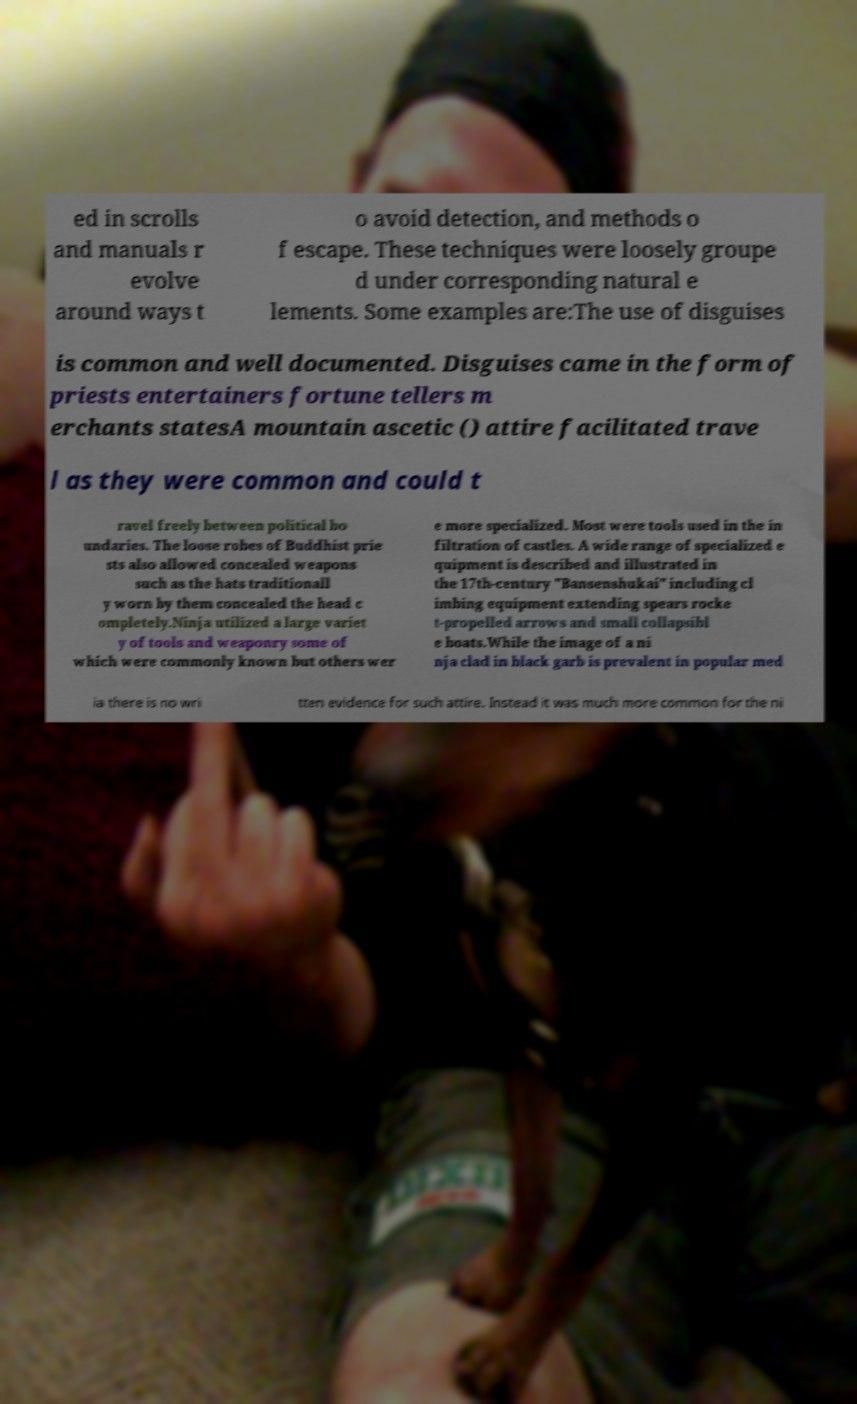There's text embedded in this image that I need extracted. Can you transcribe it verbatim? ed in scrolls and manuals r evolve around ways t o avoid detection, and methods o f escape. These techniques were loosely groupe d under corresponding natural e lements. Some examples are:The use of disguises is common and well documented. Disguises came in the form of priests entertainers fortune tellers m erchants statesA mountain ascetic () attire facilitated trave l as they were common and could t ravel freely between political bo undaries. The loose robes of Buddhist prie sts also allowed concealed weapons such as the hats traditionall y worn by them concealed the head c ompletely.Ninja utilized a large variet y of tools and weaponry some of which were commonly known but others wer e more specialized. Most were tools used in the in filtration of castles. A wide range of specialized e quipment is described and illustrated in the 17th-century "Bansenshukai" including cl imbing equipment extending spears rocke t-propelled arrows and small collapsibl e boats.While the image of a ni nja clad in black garb is prevalent in popular med ia there is no wri tten evidence for such attire. Instead it was much more common for the ni 